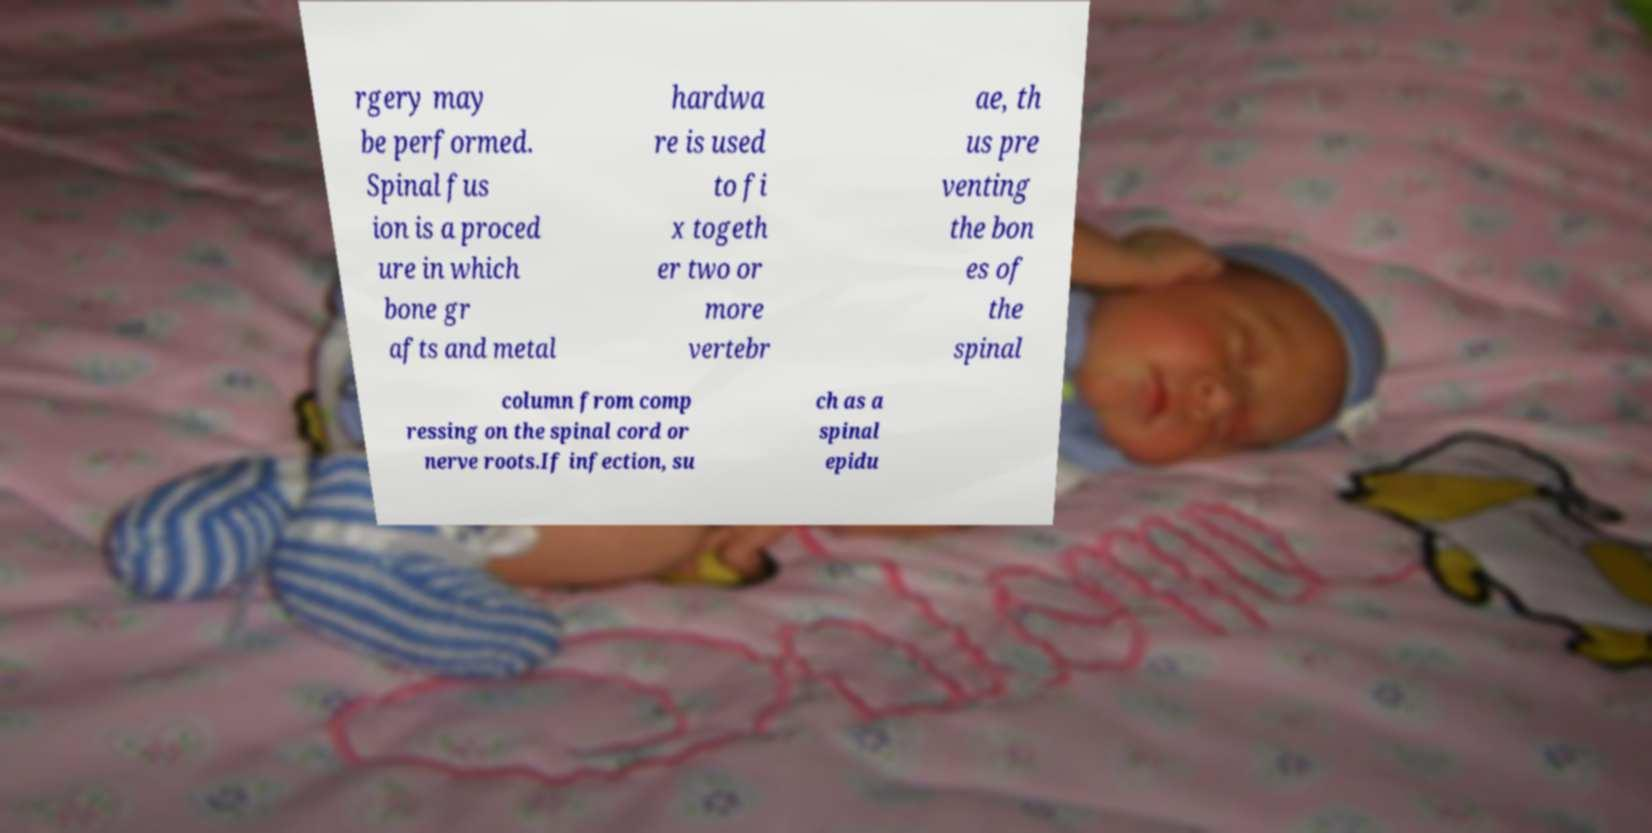I need the written content from this picture converted into text. Can you do that? rgery may be performed. Spinal fus ion is a proced ure in which bone gr afts and metal hardwa re is used to fi x togeth er two or more vertebr ae, th us pre venting the bon es of the spinal column from comp ressing on the spinal cord or nerve roots.If infection, su ch as a spinal epidu 